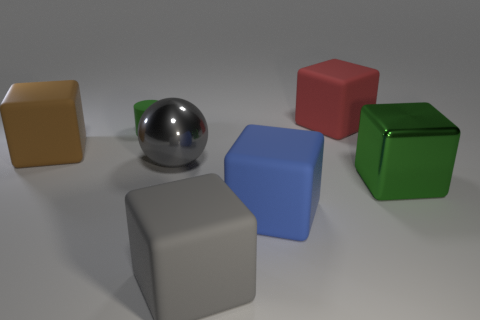How many red matte things are there?
Offer a very short reply. 1. Are there fewer large rubber blocks in front of the brown rubber thing than matte objects that are to the left of the blue matte cube?
Your response must be concise. Yes. Is the number of green rubber cylinders that are behind the red rubber thing less than the number of balls?
Keep it short and to the point. Yes. There is a brown cube to the left of the large block that is behind the big object on the left side of the matte cylinder; what is its material?
Keep it short and to the point. Rubber. What number of things are big things to the right of the large red matte thing or big gray things behind the large green block?
Provide a short and direct response. 2. What material is the red thing that is the same shape as the brown matte object?
Provide a succinct answer. Rubber. How many metal objects are small cylinders or gray cylinders?
Keep it short and to the point. 0. There is a large red thing that is made of the same material as the big brown object; what is its shape?
Make the answer very short. Cube. How many other big metal objects are the same shape as the big gray metallic thing?
Your answer should be compact. 0. Does the large metal object right of the big gray block have the same shape as the large thing left of the matte cylinder?
Your answer should be compact. Yes. 